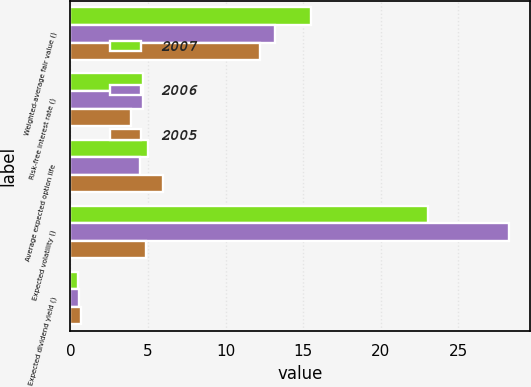<chart> <loc_0><loc_0><loc_500><loc_500><stacked_bar_chart><ecel><fcel>Weighted-average fair value ()<fcel>Risk-free interest rate ()<fcel>Average expected option life<fcel>Expected volatility ()<fcel>Expected dividend yield ()<nl><fcel>2007<fcel>15.5<fcel>4.69<fcel>5.02<fcel>23.08<fcel>0.5<nl><fcel>2006<fcel>13.19<fcel>4.67<fcel>4.51<fcel>28.24<fcel>0.54<nl><fcel>2005<fcel>12.21<fcel>3.92<fcel>5.96<fcel>4.855<fcel>0.68<nl></chart> 